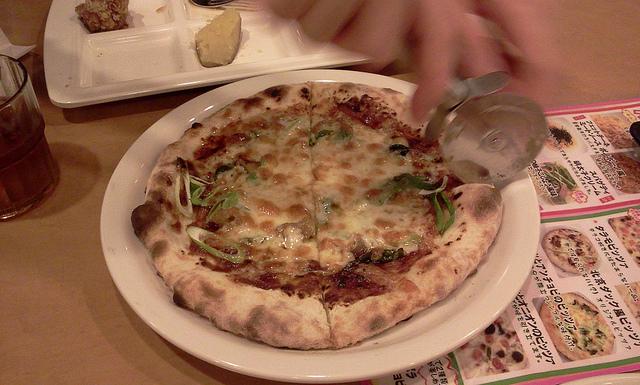Is this a thick or thin crust pizza?
Quick response, please. Thick. Is everything on the pizza baked?
Be succinct. Yes. What is being used to cut the pizza?
Give a very brief answer. Pizza cutter. Is the plate full?
Keep it brief. Yes. Can these plates be washed?
Be succinct. Yes. Is this pizza healthy?
Short answer required. No. Is this pizza too big for one person?
Answer briefly. No. Is the plate designed?
Short answer required. No. What kind of pizza is on the platter?
Keep it brief. Cheese. Is there a tablecloth?
Concise answer only. No. Is there a beverage in the image?
Keep it brief. Yes. How many drinks are shown?
Write a very short answer. 1. Is this Italian food?
Keep it brief. Yes. What kind of pizza is this?
Short answer required. Cheese. 